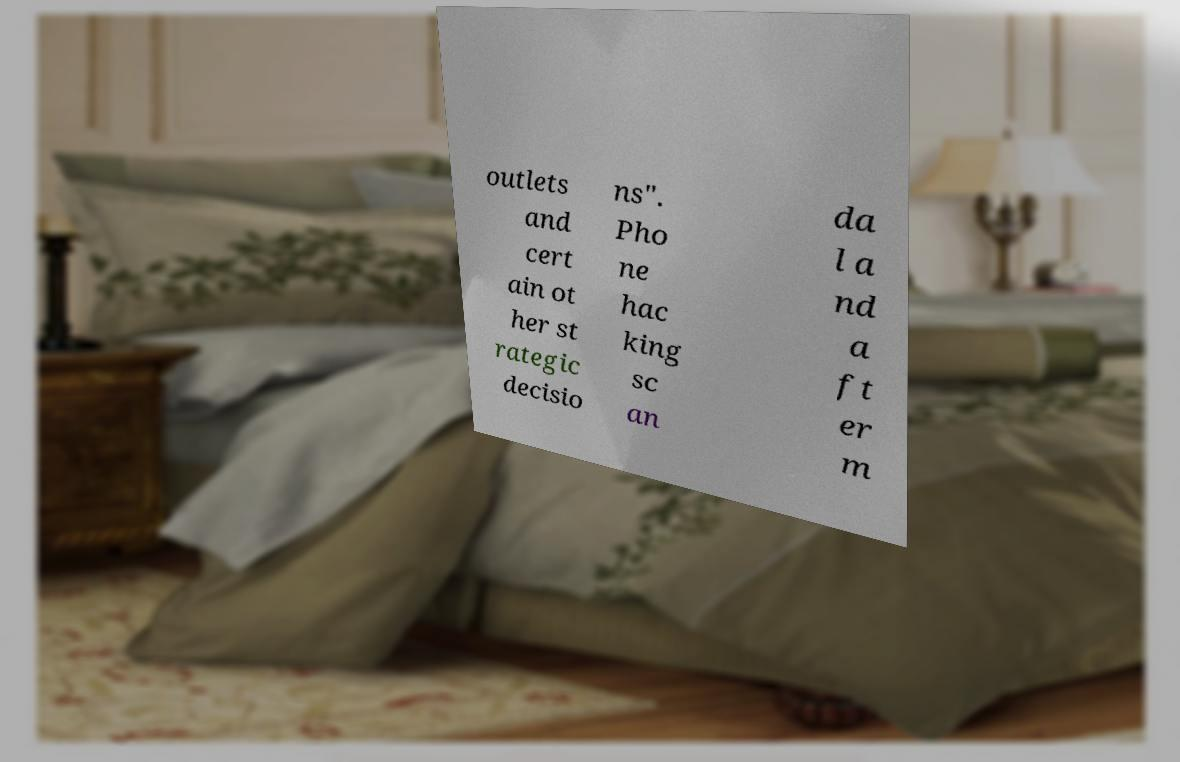Could you extract and type out the text from this image? outlets and cert ain ot her st rategic decisio ns". Pho ne hac king sc an da l a nd a ft er m 